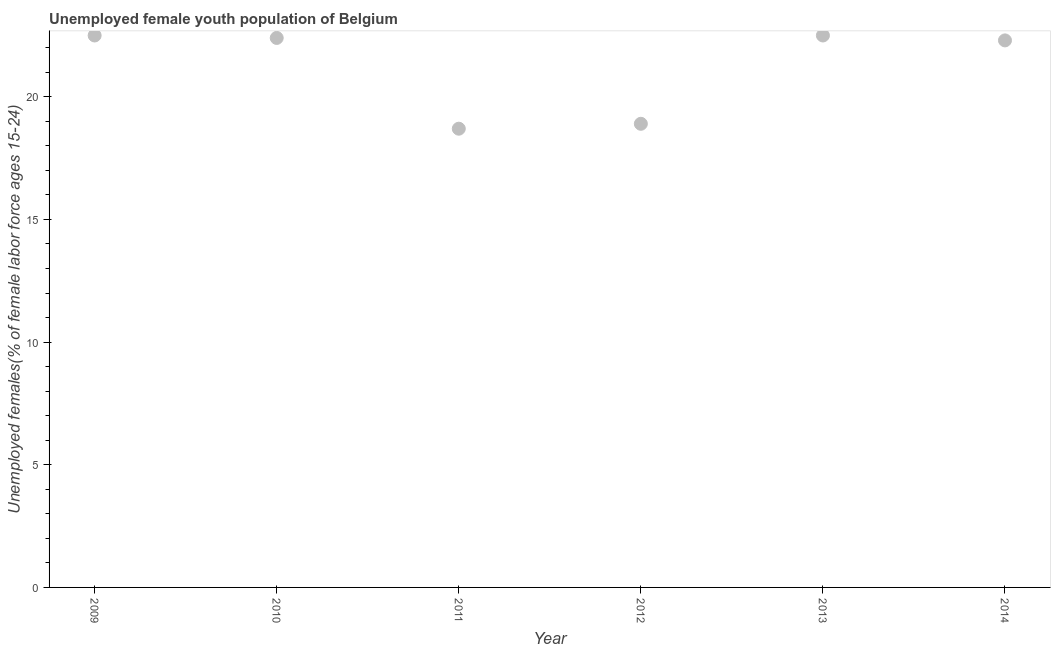What is the unemployed female youth in 2009?
Offer a terse response. 22.5. Across all years, what is the maximum unemployed female youth?
Your answer should be compact. 22.5. Across all years, what is the minimum unemployed female youth?
Make the answer very short. 18.7. In which year was the unemployed female youth maximum?
Your answer should be very brief. 2009. In which year was the unemployed female youth minimum?
Make the answer very short. 2011. What is the sum of the unemployed female youth?
Make the answer very short. 127.3. What is the difference between the unemployed female youth in 2009 and 2012?
Provide a succinct answer. 3.6. What is the average unemployed female youth per year?
Your answer should be compact. 21.22. What is the median unemployed female youth?
Your answer should be very brief. 22.35. What is the ratio of the unemployed female youth in 2009 to that in 2012?
Make the answer very short. 1.19. Is the unemployed female youth in 2010 less than that in 2013?
Offer a very short reply. Yes. Is the difference between the unemployed female youth in 2009 and 2012 greater than the difference between any two years?
Give a very brief answer. No. Is the sum of the unemployed female youth in 2009 and 2013 greater than the maximum unemployed female youth across all years?
Your response must be concise. Yes. What is the difference between the highest and the lowest unemployed female youth?
Offer a terse response. 3.8. How many dotlines are there?
Offer a very short reply. 1. How many years are there in the graph?
Give a very brief answer. 6. What is the difference between two consecutive major ticks on the Y-axis?
Provide a short and direct response. 5. Are the values on the major ticks of Y-axis written in scientific E-notation?
Ensure brevity in your answer.  No. Does the graph contain grids?
Keep it short and to the point. No. What is the title of the graph?
Offer a terse response. Unemployed female youth population of Belgium. What is the label or title of the Y-axis?
Provide a succinct answer. Unemployed females(% of female labor force ages 15-24). What is the Unemployed females(% of female labor force ages 15-24) in 2009?
Keep it short and to the point. 22.5. What is the Unemployed females(% of female labor force ages 15-24) in 2010?
Your response must be concise. 22.4. What is the Unemployed females(% of female labor force ages 15-24) in 2011?
Keep it short and to the point. 18.7. What is the Unemployed females(% of female labor force ages 15-24) in 2012?
Ensure brevity in your answer.  18.9. What is the Unemployed females(% of female labor force ages 15-24) in 2013?
Keep it short and to the point. 22.5. What is the Unemployed females(% of female labor force ages 15-24) in 2014?
Provide a short and direct response. 22.3. What is the difference between the Unemployed females(% of female labor force ages 15-24) in 2009 and 2012?
Provide a succinct answer. 3.6. What is the difference between the Unemployed females(% of female labor force ages 15-24) in 2009 and 2013?
Provide a short and direct response. 0. What is the difference between the Unemployed females(% of female labor force ages 15-24) in 2010 and 2012?
Give a very brief answer. 3.5. What is the difference between the Unemployed females(% of female labor force ages 15-24) in 2011 and 2013?
Your answer should be compact. -3.8. What is the difference between the Unemployed females(% of female labor force ages 15-24) in 2011 and 2014?
Give a very brief answer. -3.6. What is the difference between the Unemployed females(% of female labor force ages 15-24) in 2012 and 2014?
Your answer should be very brief. -3.4. What is the difference between the Unemployed females(% of female labor force ages 15-24) in 2013 and 2014?
Your response must be concise. 0.2. What is the ratio of the Unemployed females(% of female labor force ages 15-24) in 2009 to that in 2011?
Keep it short and to the point. 1.2. What is the ratio of the Unemployed females(% of female labor force ages 15-24) in 2009 to that in 2012?
Ensure brevity in your answer.  1.19. What is the ratio of the Unemployed females(% of female labor force ages 15-24) in 2009 to that in 2013?
Make the answer very short. 1. What is the ratio of the Unemployed females(% of female labor force ages 15-24) in 2009 to that in 2014?
Your answer should be compact. 1.01. What is the ratio of the Unemployed females(% of female labor force ages 15-24) in 2010 to that in 2011?
Keep it short and to the point. 1.2. What is the ratio of the Unemployed females(% of female labor force ages 15-24) in 2010 to that in 2012?
Your response must be concise. 1.19. What is the ratio of the Unemployed females(% of female labor force ages 15-24) in 2010 to that in 2013?
Your answer should be compact. 1. What is the ratio of the Unemployed females(% of female labor force ages 15-24) in 2010 to that in 2014?
Provide a short and direct response. 1. What is the ratio of the Unemployed females(% of female labor force ages 15-24) in 2011 to that in 2013?
Offer a very short reply. 0.83. What is the ratio of the Unemployed females(% of female labor force ages 15-24) in 2011 to that in 2014?
Give a very brief answer. 0.84. What is the ratio of the Unemployed females(% of female labor force ages 15-24) in 2012 to that in 2013?
Provide a short and direct response. 0.84. What is the ratio of the Unemployed females(% of female labor force ages 15-24) in 2012 to that in 2014?
Your answer should be very brief. 0.85. What is the ratio of the Unemployed females(% of female labor force ages 15-24) in 2013 to that in 2014?
Offer a terse response. 1.01. 